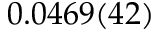<formula> <loc_0><loc_0><loc_500><loc_500>0 . 0 4 6 9 ( 4 2 )</formula> 